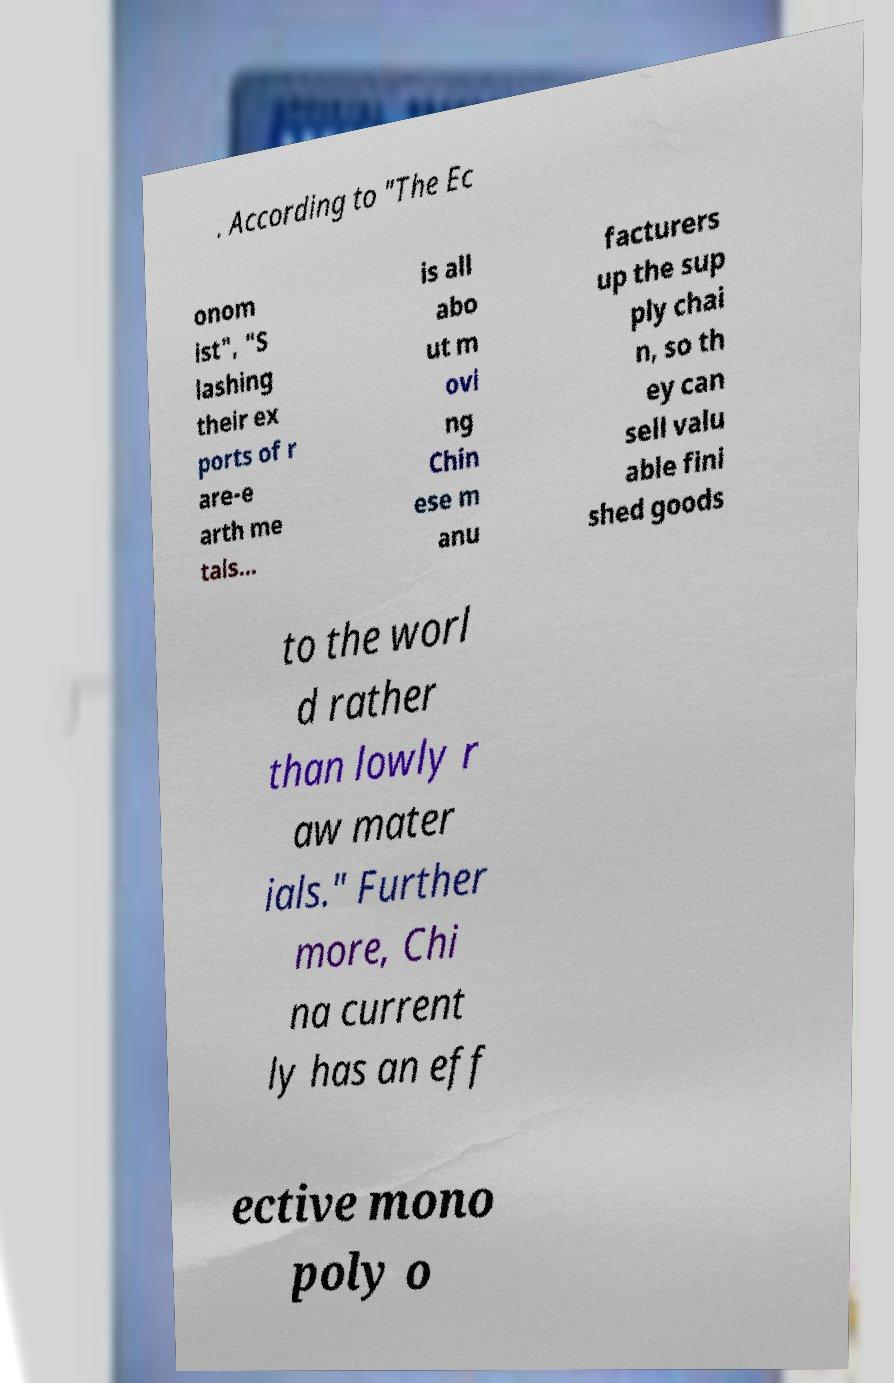Can you accurately transcribe the text from the provided image for me? . According to "The Ec onom ist", "S lashing their ex ports of r are-e arth me tals… is all abo ut m ovi ng Chin ese m anu facturers up the sup ply chai n, so th ey can sell valu able fini shed goods to the worl d rather than lowly r aw mater ials." Further more, Chi na current ly has an eff ective mono poly o 